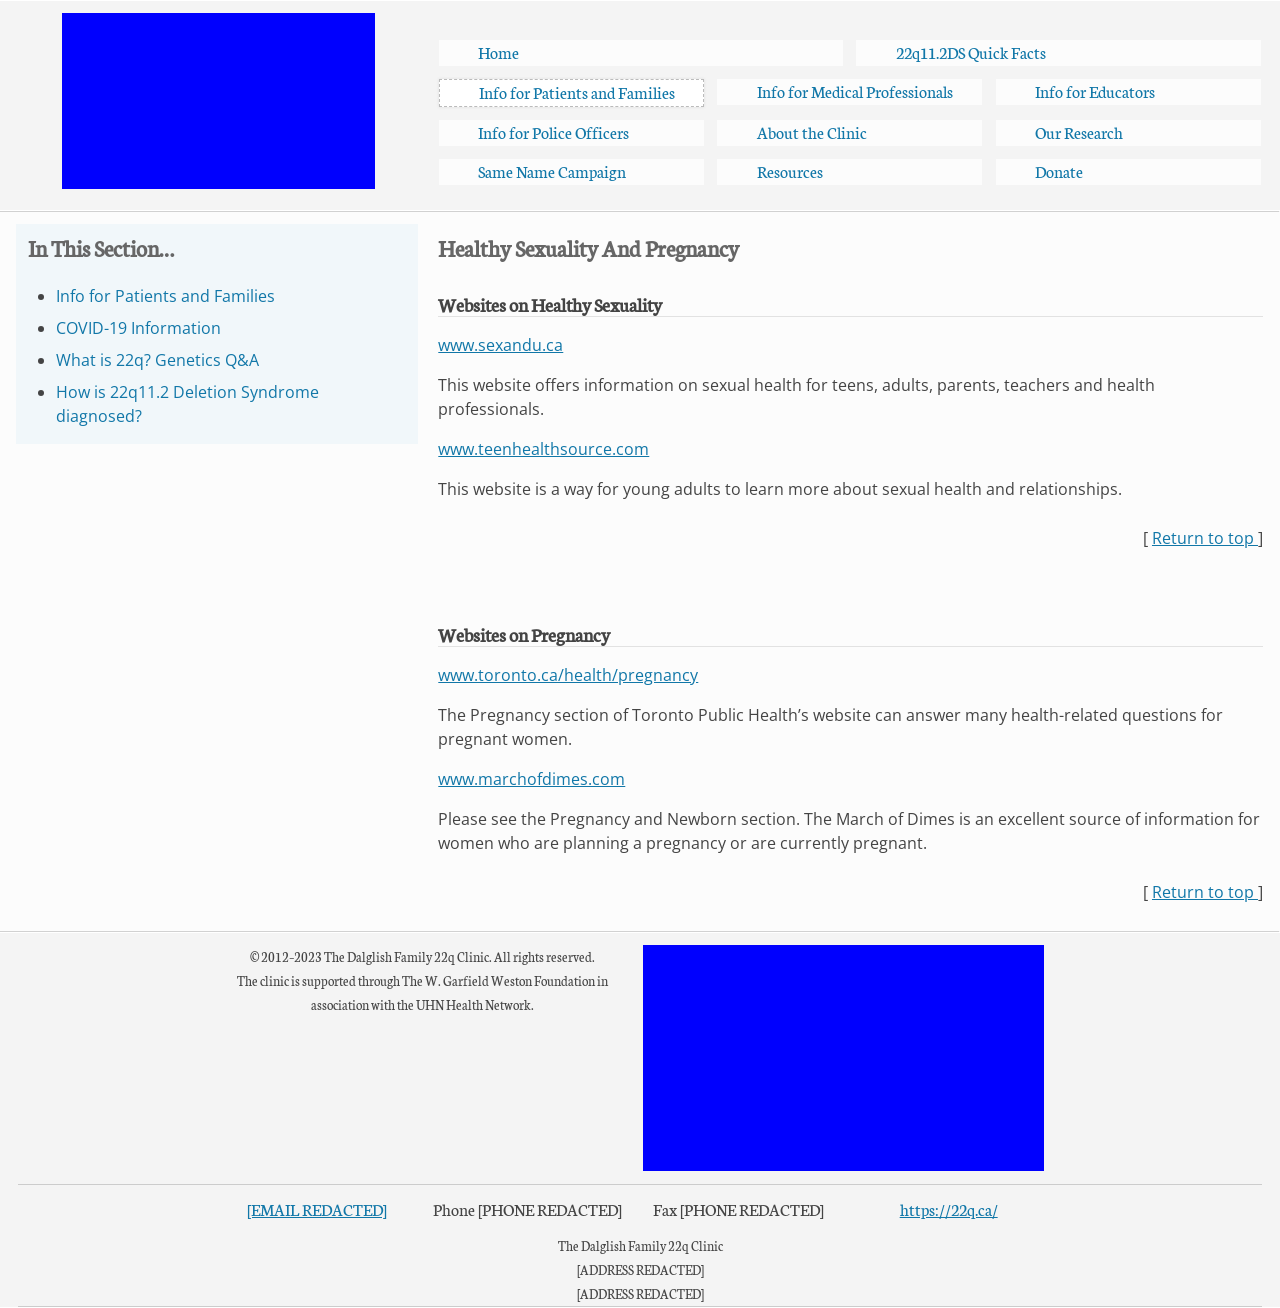Could you suggest some accessibility improvements for the web design shown? Improving accessibility could include ensuring all images have descriptive alt attributes, using semantic HTML tags like <main>, <aside>, and <nav> to better define the structure. Ensuring adequate contrast between text and background colors, providing text alternatives or captions for video content, and making sure the website can be navigated using keyboard shortcuts would also help. Accessibility can further be enhanced by conforming to WCAG (Web Content Accessibility Guidelines) standards. 